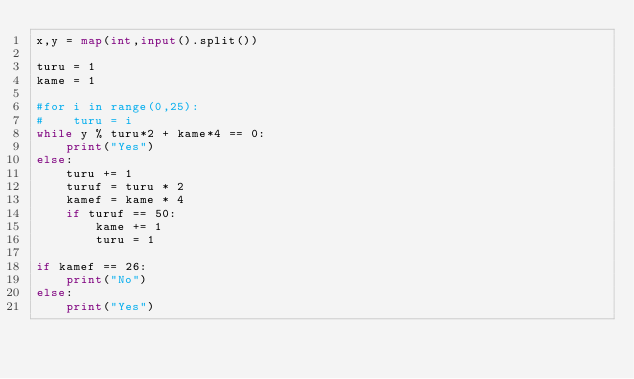<code> <loc_0><loc_0><loc_500><loc_500><_Python_>x,y = map(int,input().split())

turu = 1
kame = 1

#for i in range(0,25):
#    turu = i
while y % turu*2 + kame*4 == 0:
	print("Yes")
else:
    turu += 1
    turuf = turu * 2
    kamef = kame * 4
    if turuf == 50:
        kame += 1
        turu = 1

if kamef == 26:
	print("No")
else:
	print("Yes")

    </code> 